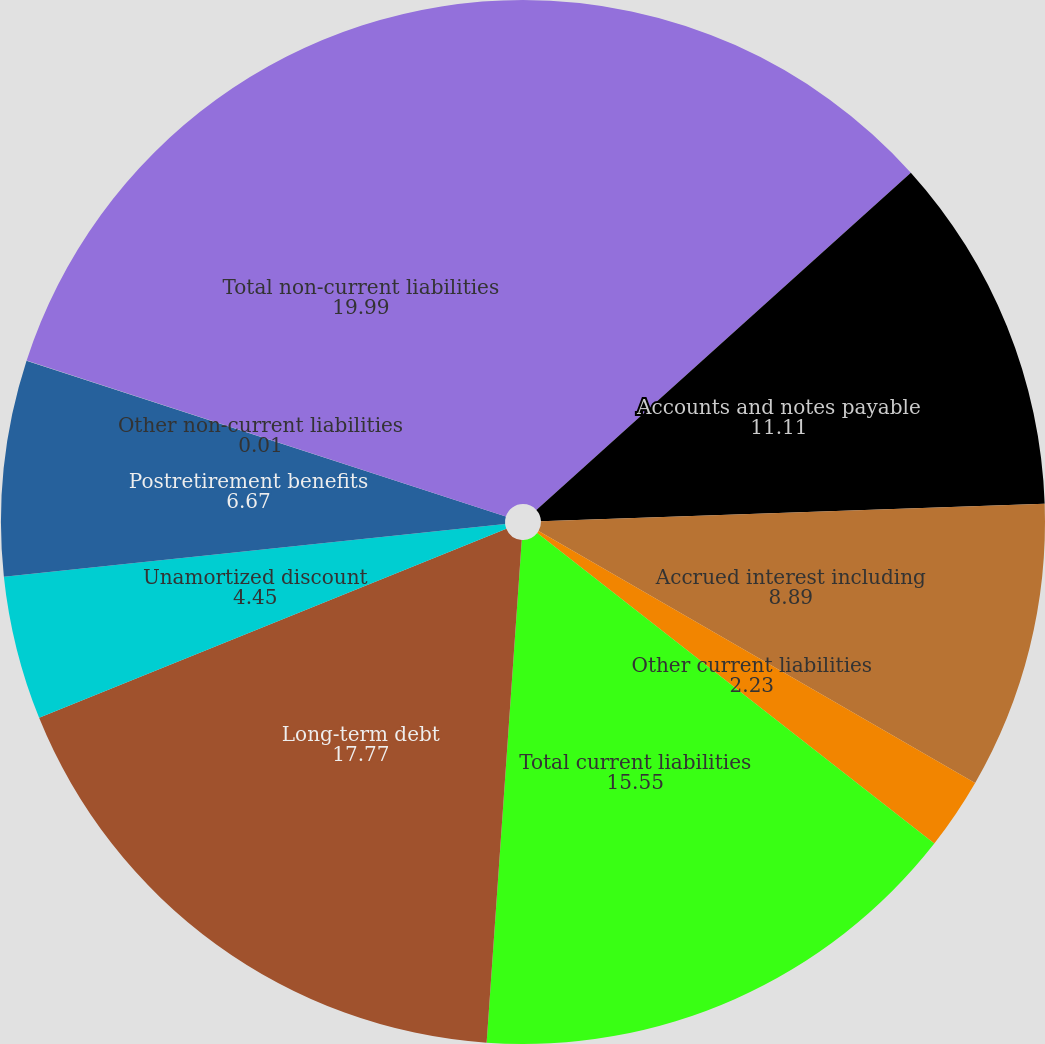Convert chart. <chart><loc_0><loc_0><loc_500><loc_500><pie_chart><fcel>Current portion of long-term<fcel>Accounts and notes payable<fcel>Accrued interest including<fcel>Other current liabilities<fcel>Total current liabilities<fcel>Long-term debt<fcel>Unamortized discount<fcel>Postretirement benefits<fcel>Other non-current liabilities<fcel>Total non-current liabilities<nl><fcel>13.33%<fcel>11.11%<fcel>8.89%<fcel>2.23%<fcel>15.55%<fcel>17.77%<fcel>4.45%<fcel>6.67%<fcel>0.01%<fcel>19.99%<nl></chart> 